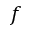<formula> <loc_0><loc_0><loc_500><loc_500>f</formula> 